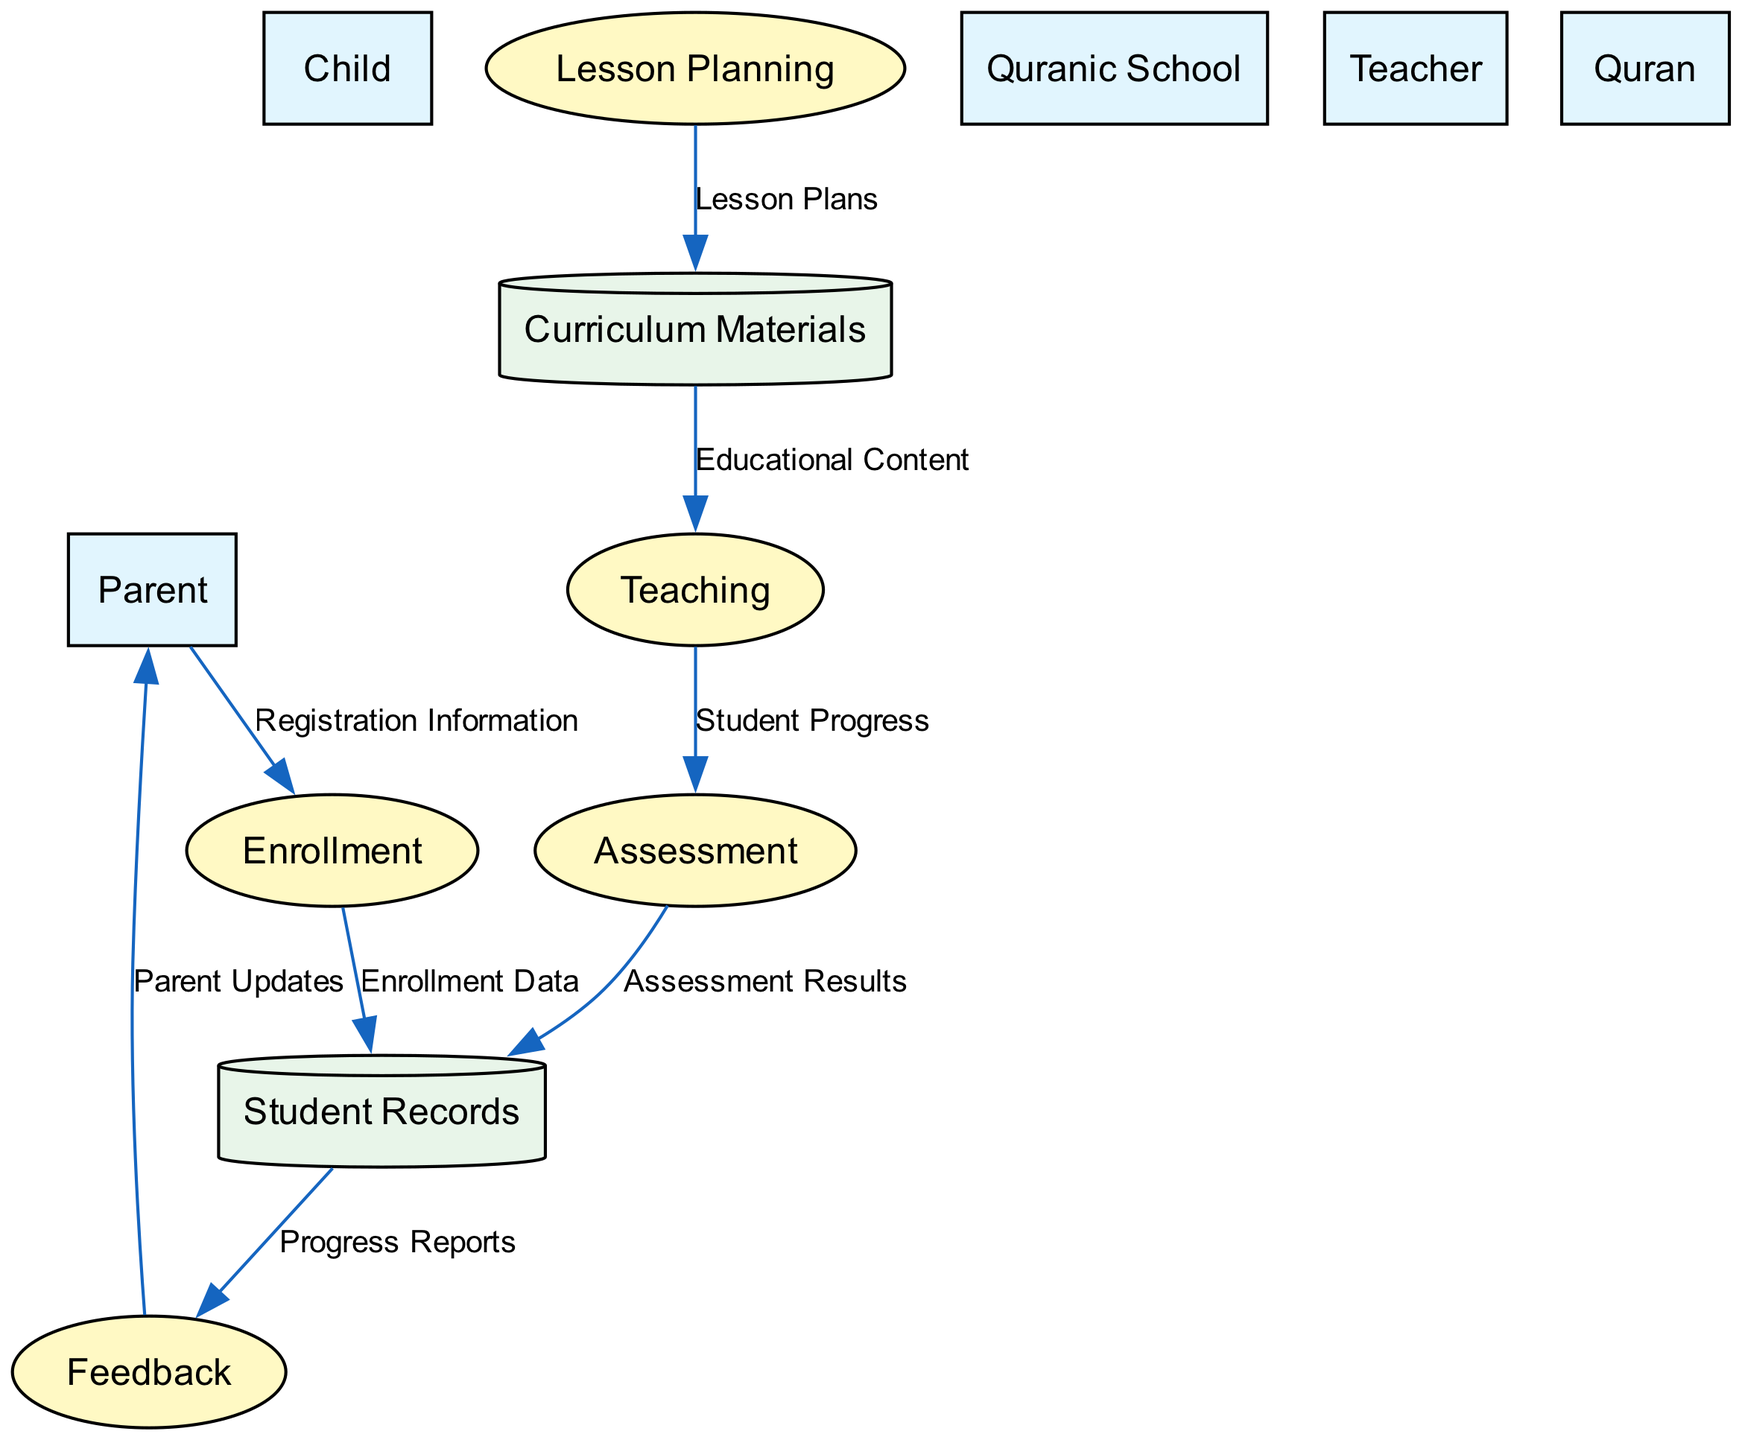What is the primary learner in the Quranic education process? According to the entities in the diagram, the primary learner is identified as the "Child," who is the recipient of Quranic education.
Answer: Child How many processes are involved in the Quranic education process? By counting the processes listed in the diagram, there are a total of five processes: Enrollment, Lesson Planning, Teaching, Assessment, and Feedback.
Answer: 5 Who provides the registration information for enrollment? The source of the "Registration Information" data flow, as shown in the diagram, is the "Parent," who provides the necessary information to enroll the child into the Quranic school.
Answer: Parent What type of data store contains information about students? The data store that holds information about the students, including their progress and assessments, is labeled as "Student Records" in the diagram.
Answer: Student Records What is the relationship between the "Teaching" process and the "Assessment" process? The "Teaching" process provides the data flow labeled "Student Progress" to the "Assessment" process, indicating a direct connection where the ongoing progress of the child is assessed after teaching.
Answer: Student Progress What information do parents receive from the Feedback process? The output from the "Feedback" process is indicated by the data flow labeled "Parent Updates," which provides the parents with information about their child's performance and progress.
Answer: Parent Updates Which process is responsible for structuring the curriculum? The process dedicated to structuring the curriculum in accordance with Quranic teachings is referred to as "Lesson Planning," based on the processes listed in the diagram.
Answer: Lesson Planning What is the output of the Assessment process? The output from the "Assessment" process is represented by the data flow labeled "Assessment Results," which takes the evaluation results from the assessment and stores them in the "Student Records."
Answer: Assessment Results How does teaching content flow from Curriculum Materials? The teaching content flows from the "Curriculum Materials" data store to the "Teaching" process through the data flow identified as "Educational Content," supplying the necessary materials for education.
Answer: Educational Content Which entity oversees and supports the child's Quranic education? The entity responsible for overseeing and supporting the child's Quranic education is the "Parent," who plays a crucial role in the process according to the diagram.
Answer: Parent 